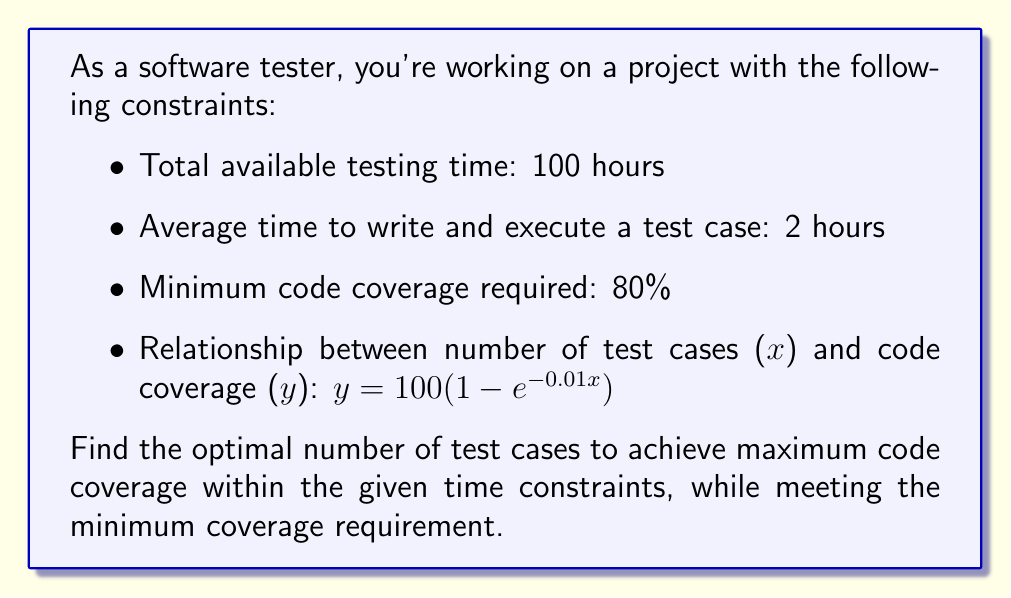Help me with this question. Let's approach this step-by-step:

1) First, we need to consider the time constraint. With 100 hours available and each test case taking 2 hours:
   Maximum number of test cases = $\frac{100 \text{ hours}}{2 \text{ hours/case}} = 50$ cases

2) Now, let's look at the code coverage function:
   $y = 100(1 - e^{-0.01x})$, where x is the number of test cases and y is the percentage of code coverage.

3) We need to ensure that the coverage is at least 80%:
   $80 \leq 100(1 - e^{-0.01x})$
   $0.8 \leq 1 - e^{-0.01x}$
   $e^{-0.01x} \leq 0.2$
   $-0.01x \leq \ln(0.2)$
   $x \geq -100\ln(0.2) \approx 160.94$

4) However, we can only have a maximum of 50 test cases due to time constraints. So, we need to use all 50 test cases to get the maximum possible coverage.

5) To find the actual coverage with 50 test cases:
   $y = 100(1 - e^{-0.01(50)}) \approx 39.35\%$

6) Unfortunately, this doesn't meet the minimum required coverage of 80%.

7) To achieve 80% coverage, we would need:
   $x \geq -100\ln(0.2) \approx 160.94$ test cases, which is not possible within the given time constraint.

Therefore, it's not possible to achieve the required 80% code coverage within the given time constraints.
Answer: The optimal number of test cases is 50, which is the maximum possible within the time constraint. However, this only achieves approximately 39.35% code coverage, which does not meet the minimum requirement of 80%. The project constraints need to be adjusted to make the goal achievable. 